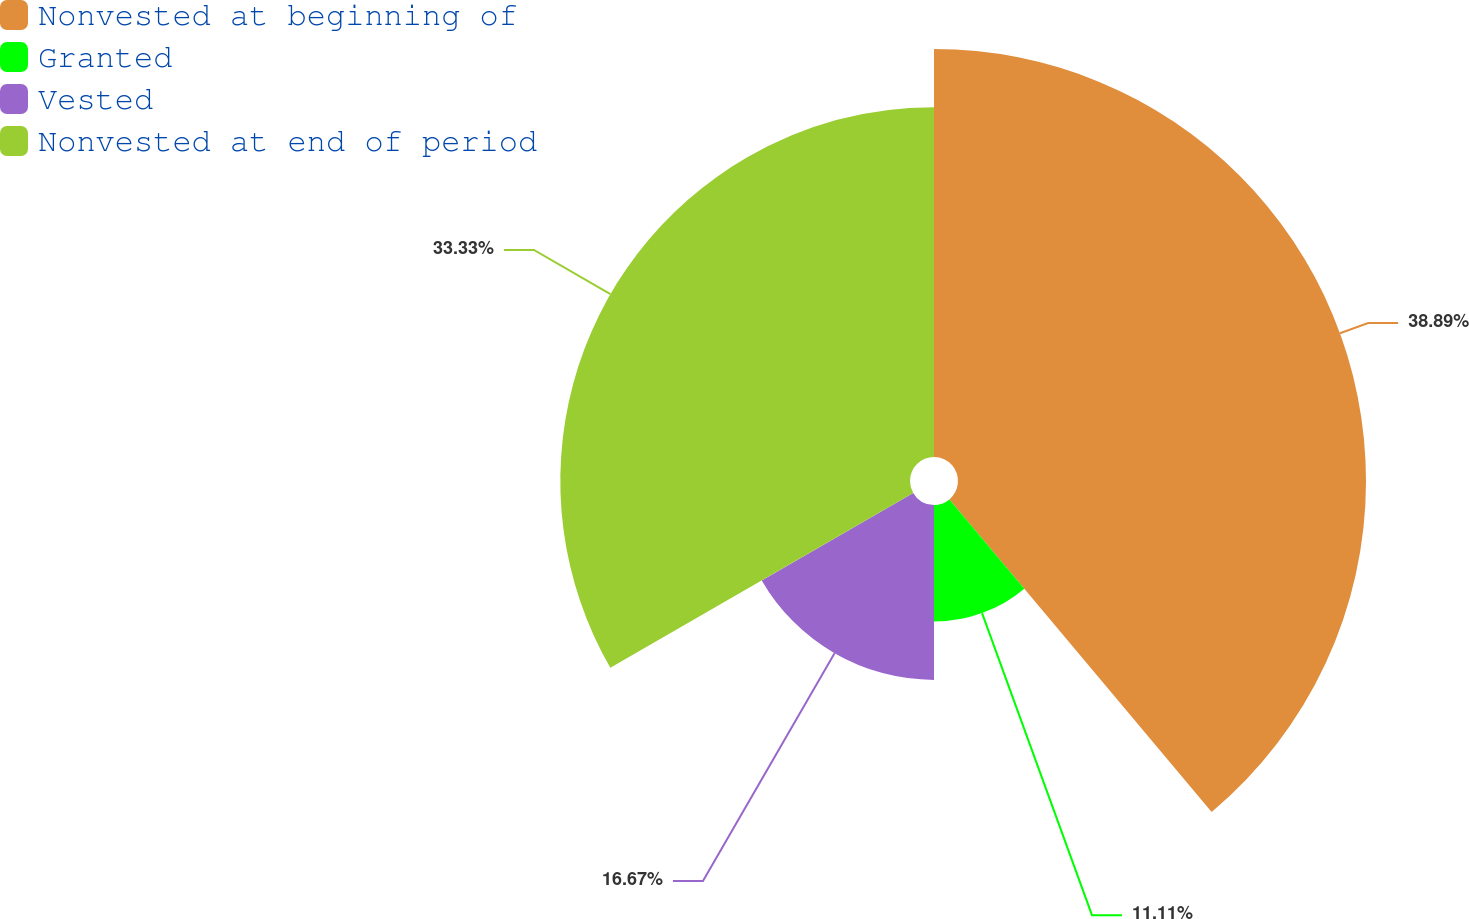Convert chart to OTSL. <chart><loc_0><loc_0><loc_500><loc_500><pie_chart><fcel>Nonvested at beginning of<fcel>Granted<fcel>Vested<fcel>Nonvested at end of period<nl><fcel>38.89%<fcel>11.11%<fcel>16.67%<fcel>33.33%<nl></chart> 